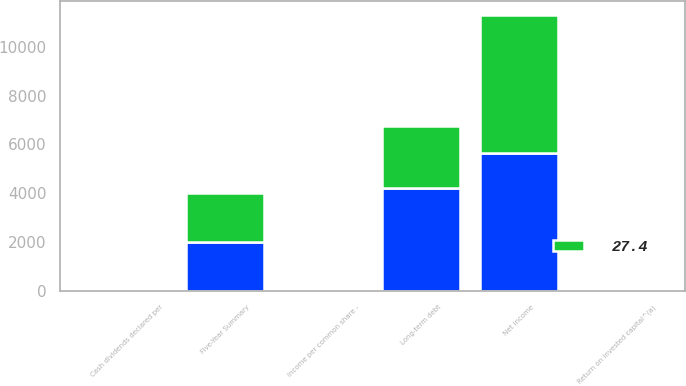Convert chart. <chart><loc_0><loc_0><loc_500><loc_500><stacked_bar_chart><ecel><fcel>Five-Year Summary<fcel>Net income<fcel>Income per common share -<fcel>Cash dividends declared per<fcel>Long-term debt<fcel>Return on invested capital^(a)<nl><fcel>nan<fcel>2007<fcel>5658<fcel>3.41<fcel>1.43<fcel>4203<fcel>28.9<nl><fcel>27.4<fcel>2006<fcel>5642<fcel>3.34<fcel>1.16<fcel>2550<fcel>30.4<nl></chart> 